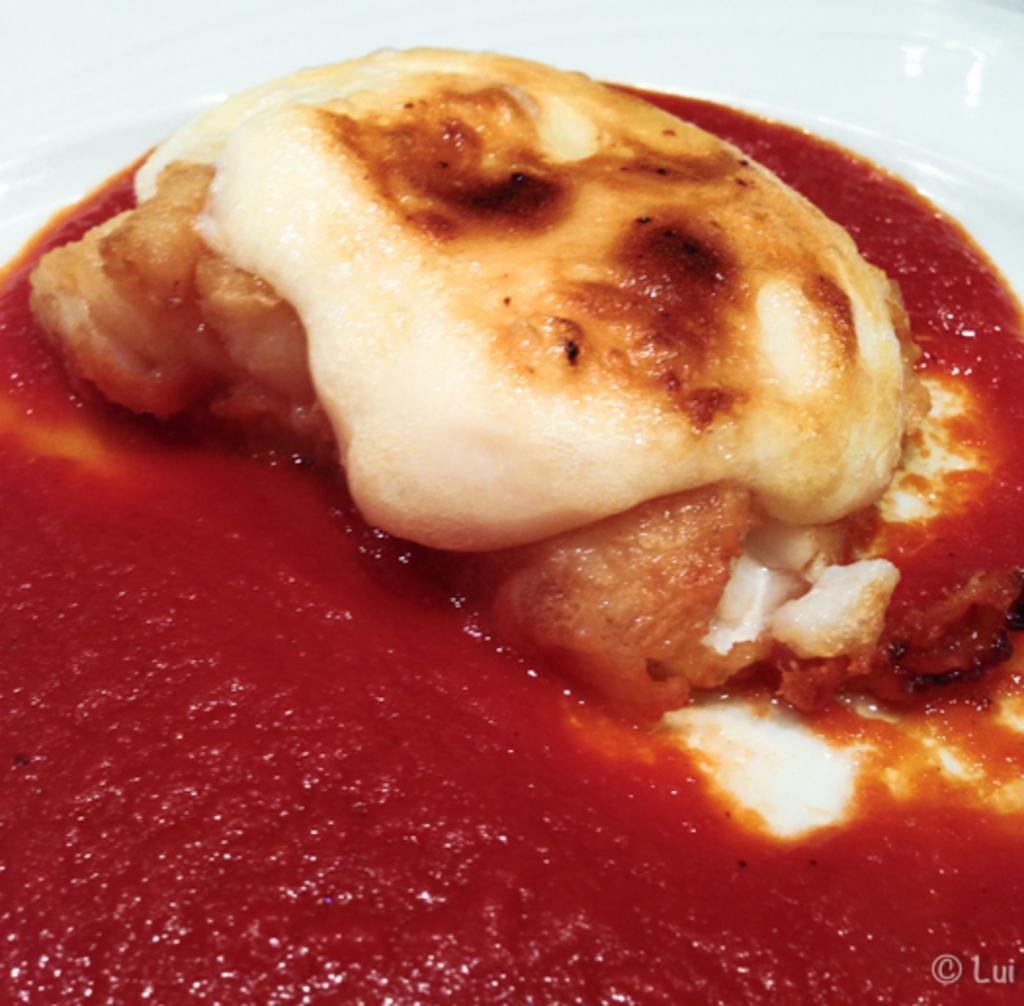What is on the plate that is visible in the image? There is a food item with sauce on the plate in the image. What color is the plate in the image? The plate in the image is white. Is there any additional information visible in the image? Yes, there is a watermark in the bottom right corner of the image. How many balloons are floating above the plate in the image? There are no balloons present in the image. What type of chairs are visible in the image? There are no chairs visible in the image. 